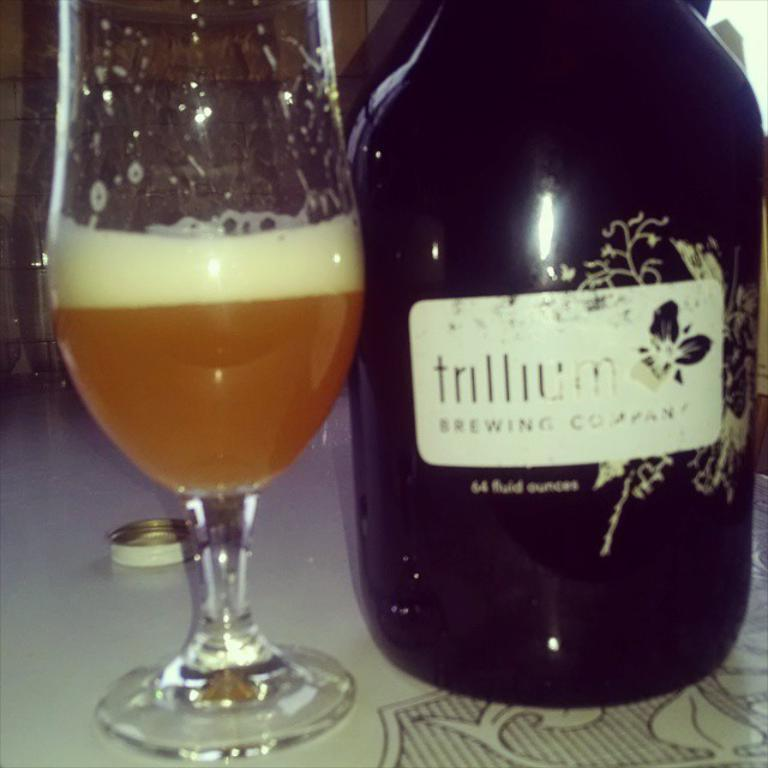<image>
Summarize the visual content of the image. A beverage from the trillium brewing company poured in a glass 